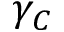<formula> <loc_0><loc_0><loc_500><loc_500>\gamma _ { C }</formula> 